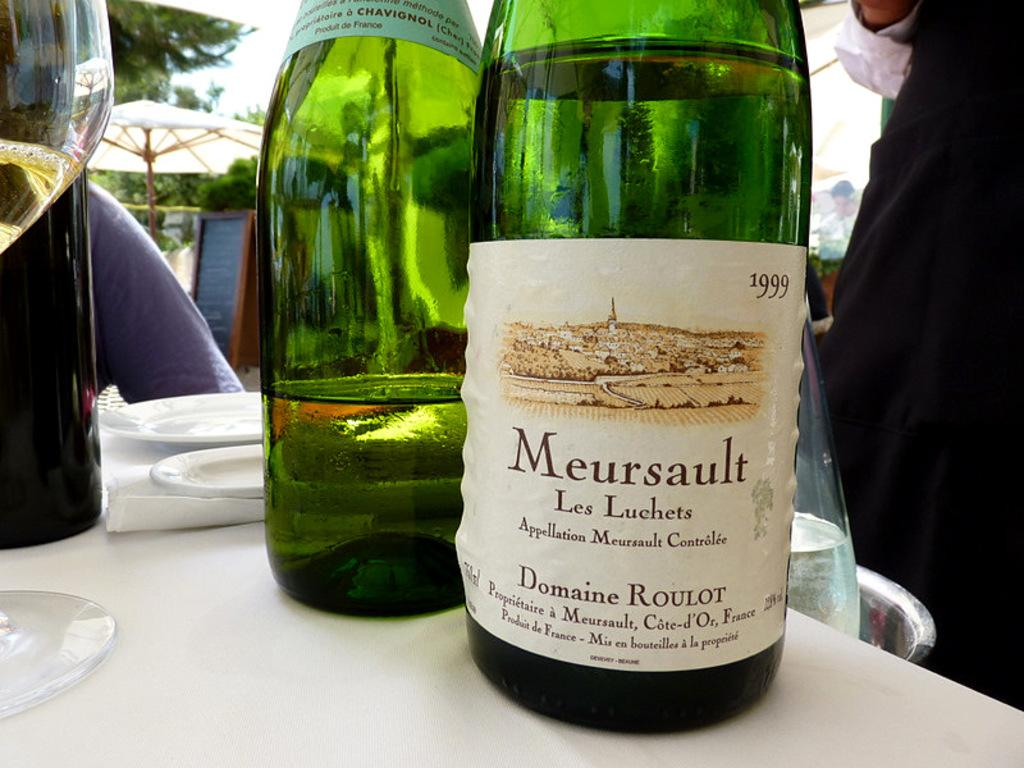<image>
Offer a succinct explanation of the picture presented. Two green bottles of wine say Meursault on the label. 